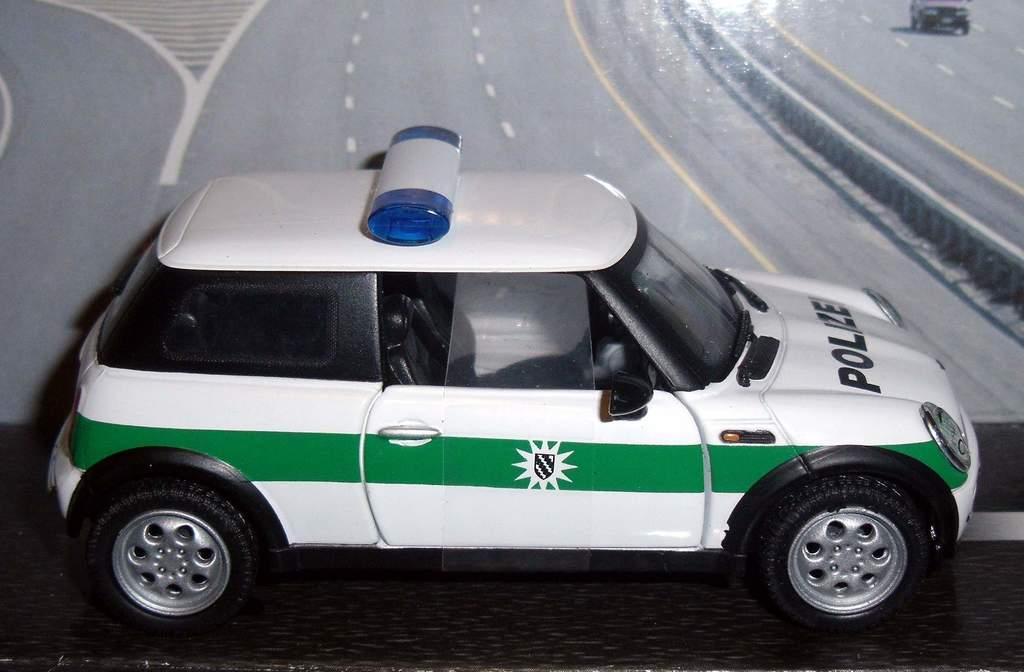What is the main subject of the image? The main subject of the image is a car. What is written on the car? "Police" is written on the car. What colors is the car in the image? The car is in white and green color. Can you see the edge of the seashore in the image? There is no seashore present in the image; it features a car with "police" written on it. Who is the creator of the car in the image? The image does not provide information about the creator of the car. 